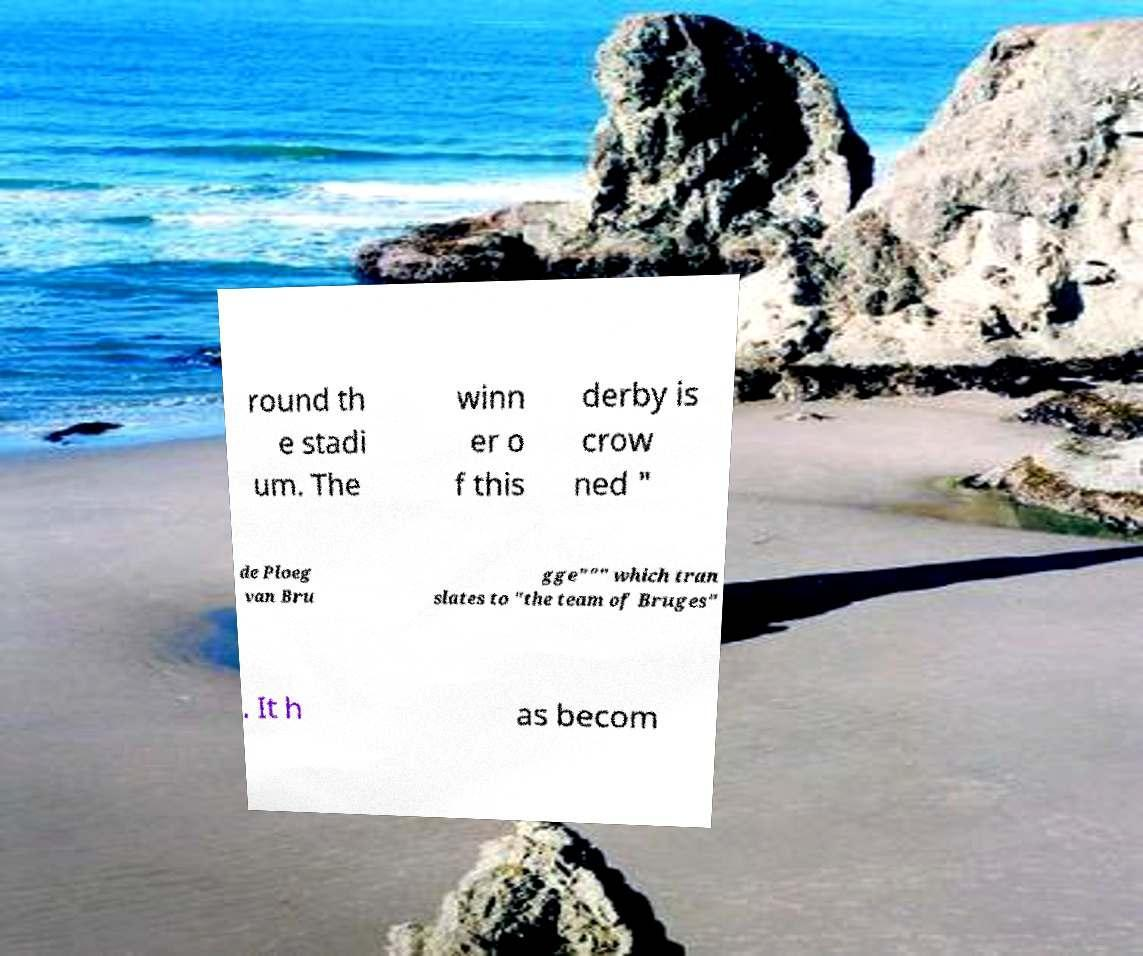I need the written content from this picture converted into text. Can you do that? round th e stadi um. The winn er o f this derby is crow ned " de Ploeg van Bru gge""" which tran slates to "the team of Bruges" . It h as becom 